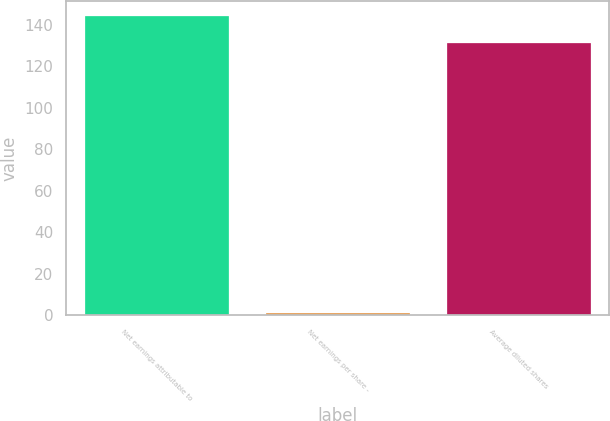Convert chart. <chart><loc_0><loc_0><loc_500><loc_500><bar_chart><fcel>Net earnings attributable to<fcel>Net earnings per share -<fcel>Average diluted shares<nl><fcel>144.15<fcel>1.01<fcel>131<nl></chart> 